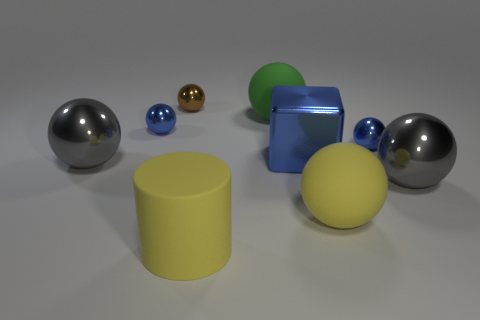Subtract all gray cylinders. Subtract all yellow cubes. How many cylinders are left? 1 Subtract all red blocks. How many yellow spheres are left? 1 Add 8 grays. How many greens exist? 0 Subtract all large yellow spheres. Subtract all cyan metal cylinders. How many objects are left? 8 Add 1 big green rubber objects. How many big green rubber objects are left? 2 Add 2 large cylinders. How many large cylinders exist? 3 Add 1 rubber balls. How many objects exist? 10 Subtract all brown balls. How many balls are left? 6 Subtract all tiny brown spheres. How many spheres are left? 6 Subtract 0 brown cylinders. How many objects are left? 9 